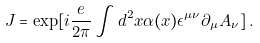Convert formula to latex. <formula><loc_0><loc_0><loc_500><loc_500>J = \exp [ i \frac { e } { 2 \pi } \int d ^ { 2 } x \alpha ( x ) \epsilon ^ { \mu \nu } \partial _ { \mu } A _ { \nu } ] \, .</formula> 